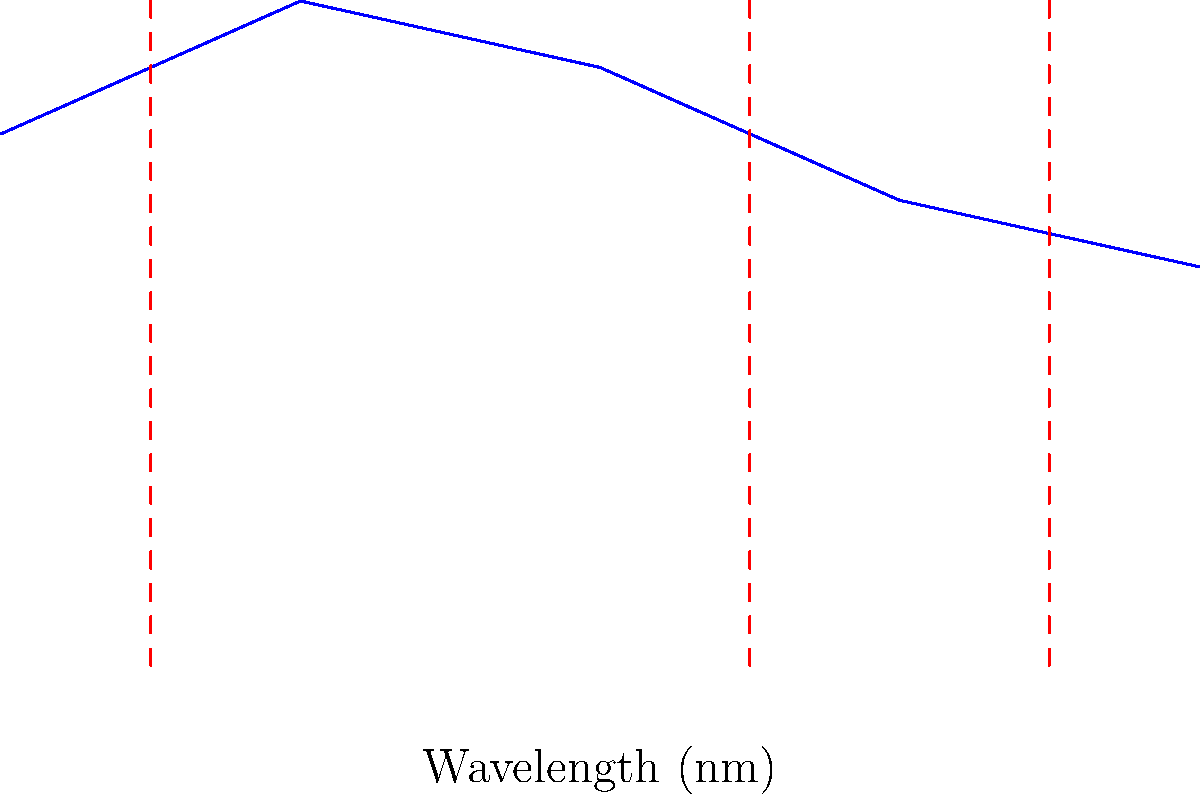Analyze the spectral data of the asteroid shown in the graph above. Based on the absorption lines, what can you conclude about the elemental composition of this asteroid? Additionally, calculate the approximate abundance ratio of Fe to Mg, assuming their absorption strengths are directly proportional to their abundances. 1. Identify absorption lines:
   The graph shows three distinct absorption lines at 450 nm, 650 nm, and 750 nm.

2. Associate elements with absorption lines:
   - 450 nm: Iron (Fe)
   - 650 nm: Magnesium (Mg)
   - 750 nm: Silicon (Si)

3. Interpret elemental composition:
   The presence of these absorption lines indicates that the asteroid contains iron, magnesium, and silicon.

4. Analyze relative abundances:
   To estimate the abundance ratio of Fe to Mg, we need to compare the strength of their absorption lines.

5. Calculate absorption strength:
   Absorption strength = 1 - Relative intensity at the absorption wavelength
   Fe (450 nm): 1 - 0.8 = 0.2
   Mg (650 nm): 1 - 0.7 = 0.3

6. Calculate abundance ratio:
   Fe:Mg ratio = Absorption strength of Fe : Absorption strength of Mg
   Fe:Mg ratio = 0.2 : 0.3 = 2 : 3

7. Simplify ratio:
   Fe:Mg ≈ 0.67 : 1
Answer: The asteroid contains Fe, Mg, and Si. Fe:Mg abundance ratio ≈ 0.67:1. 